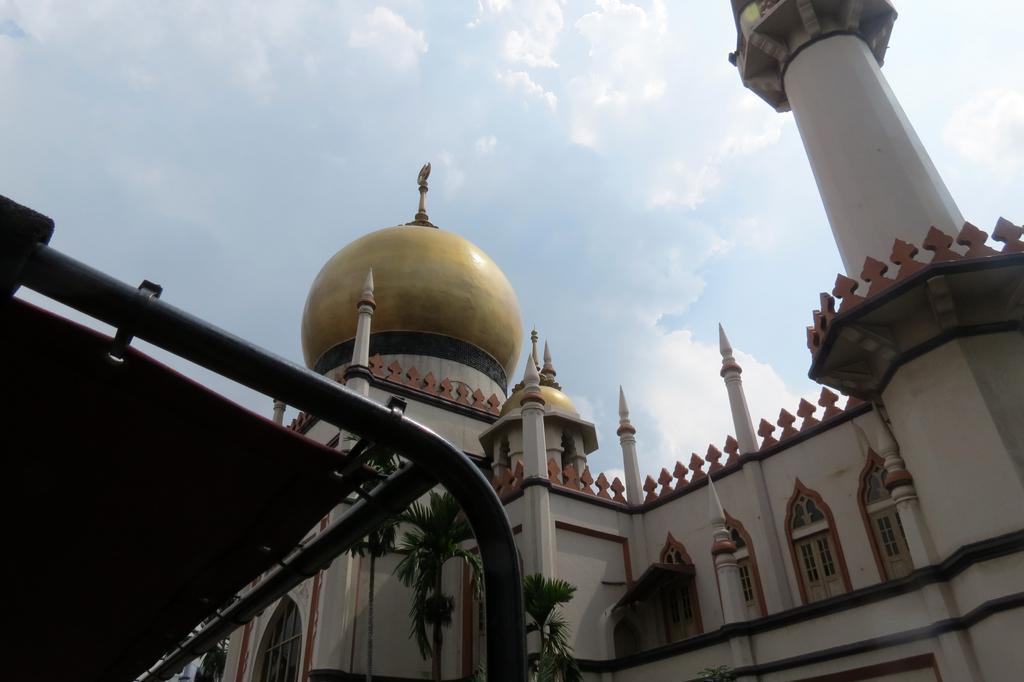How would you summarize this image in a sentence or two? In this image I can see building which is in white,black and gold color. We can see windows and trees. The sky is in white and blue color. 